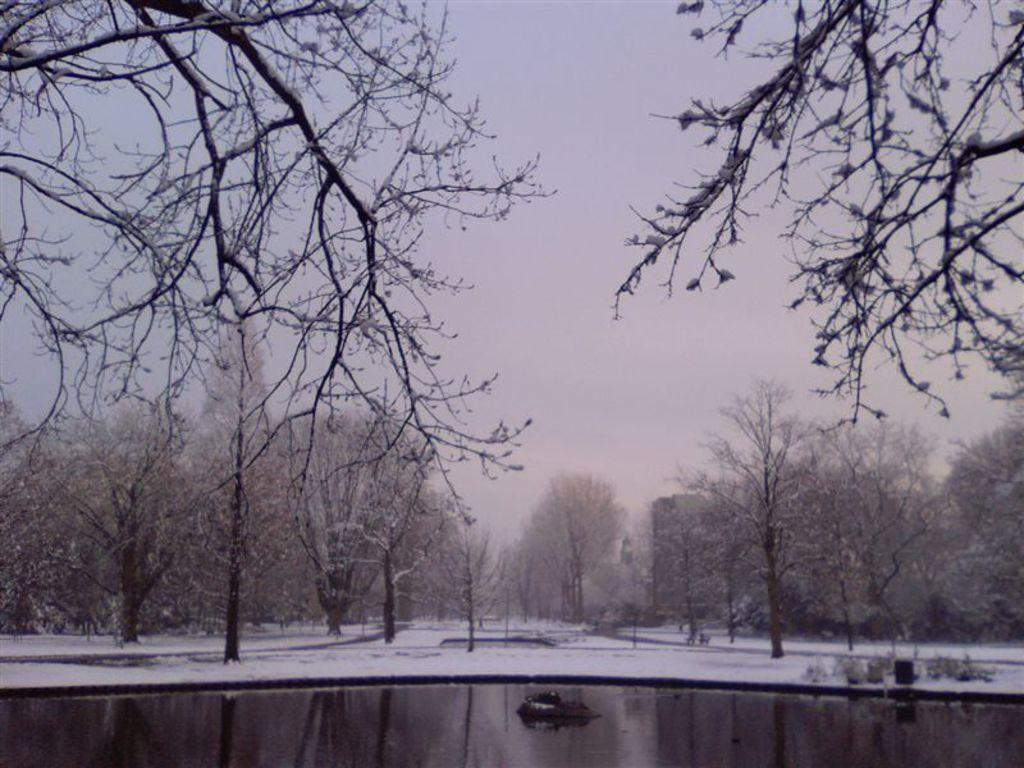What is the main focus of the image? The center of the image contains the sky, trees, snow, water, and other objects. Can you describe the objects visible at the top of the image? Branches are visible at the top of the image. What type of magic is being performed in the image? There is no magic or any indication of a magical performance in the image. Can you hear any music playing in the image? The image does not contain any audible elements, so it is impossible to determine if music is playing. 